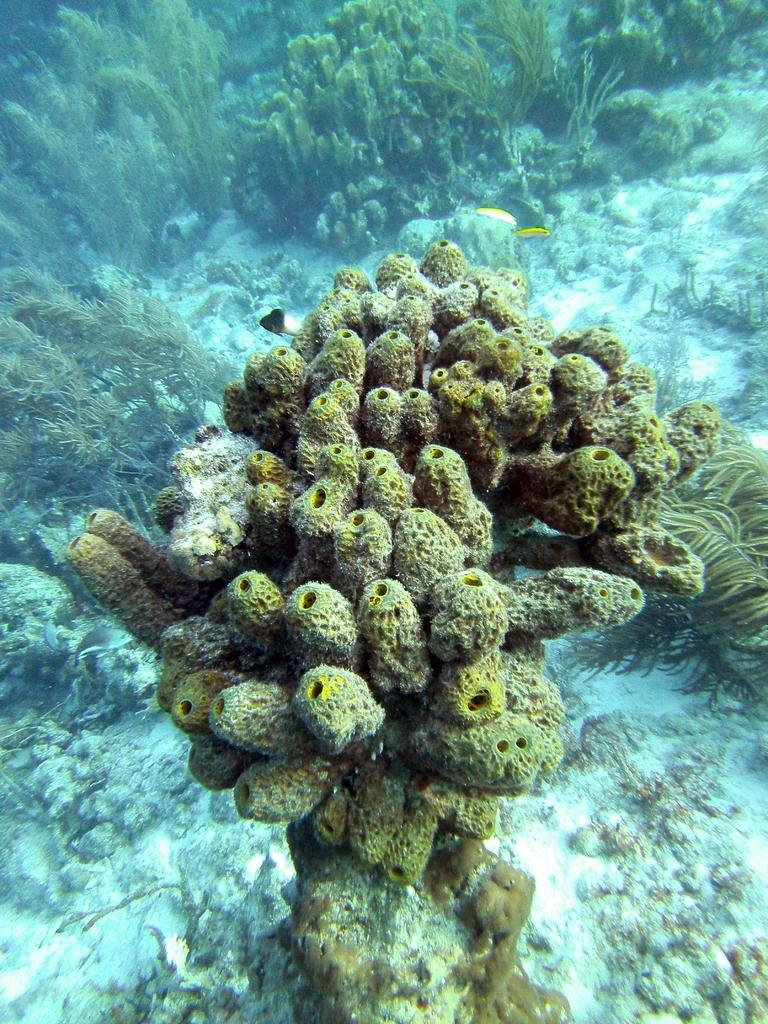What type of environment is shown in the image? The image depicts an underwater environment. Can you describe any specific features of the underwater environment? Unfortunately, the provided facts do not include any specific features of the underwater environment. Are there any living organisms visible in the image? The provided facts do not mention any living organisms in the image. How many bears can be seen in the underwater environment in the image? There are no bears present in the underwater environment depicted in the image. 